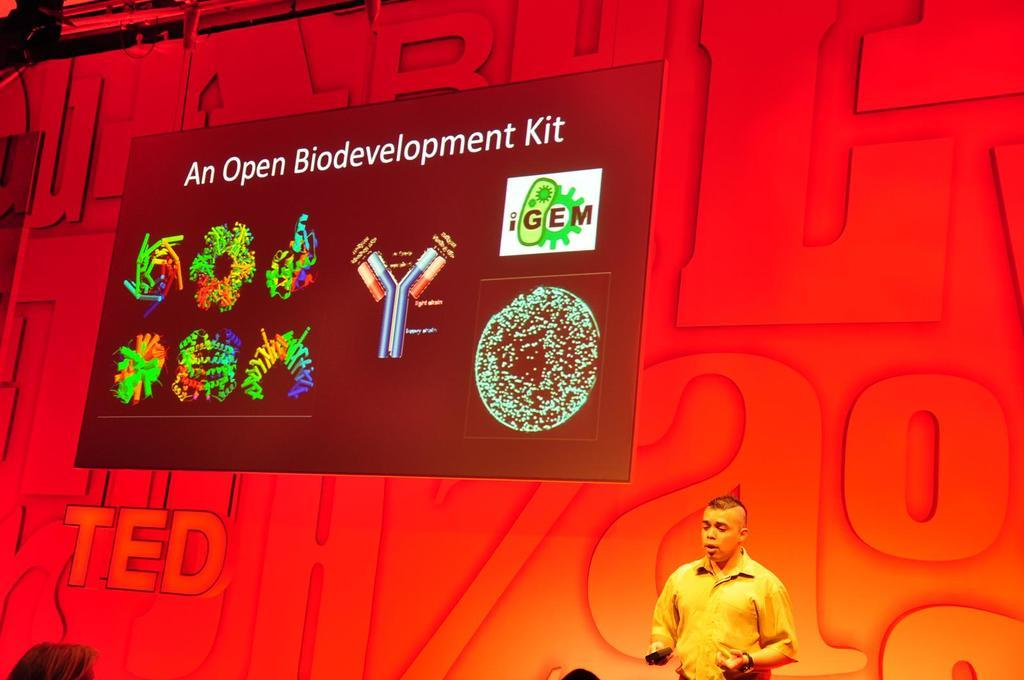What is the location of the person in the image? The person is on the right side of the image. What can be seen behind the person in the image? There is a wall in the image. What is attached to the wall in the image? There is a banner on the wall, as well as images and text. What type of crayon is being used to write on the wall in the image? There is no crayon present in the image, and no writing is being done on the wall. 